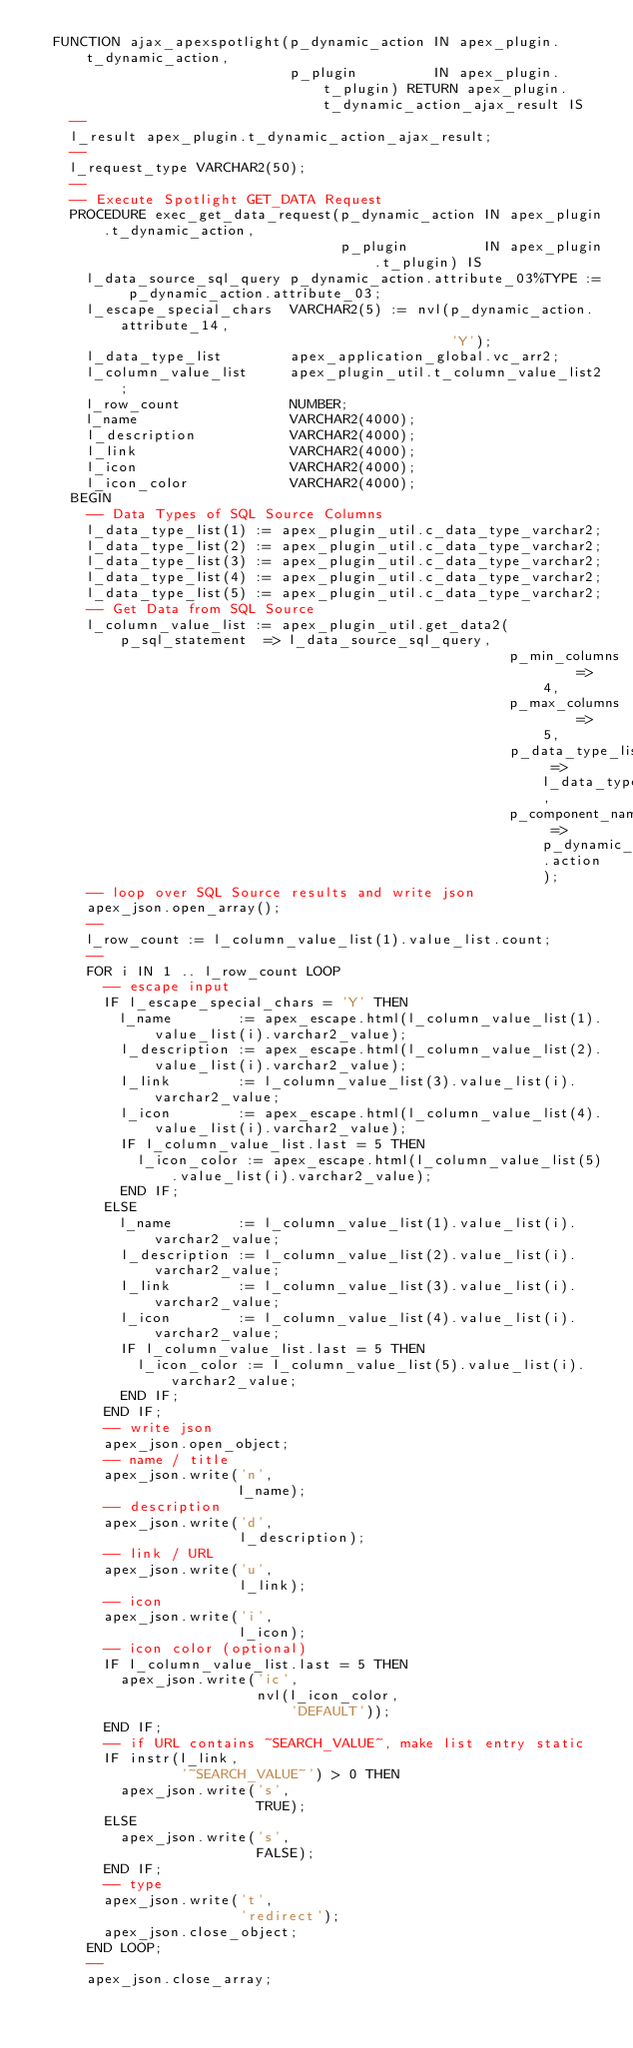Convert code to text. <code><loc_0><loc_0><loc_500><loc_500><_SQL_>  FUNCTION ajax_apexspotlight(p_dynamic_action IN apex_plugin.t_dynamic_action,
                              p_plugin         IN apex_plugin.t_plugin) RETURN apex_plugin.t_dynamic_action_ajax_result IS
    --
    l_result apex_plugin.t_dynamic_action_ajax_result;
    --
    l_request_type VARCHAR2(50);
    --
    -- Execute Spotlight GET_DATA Request
    PROCEDURE exec_get_data_request(p_dynamic_action IN apex_plugin.t_dynamic_action,
                                    p_plugin         IN apex_plugin.t_plugin) IS
      l_data_source_sql_query p_dynamic_action.attribute_03%TYPE := p_dynamic_action.attribute_03;
      l_escape_special_chars  VARCHAR2(5) := nvl(p_dynamic_action.attribute_14,
                                                 'Y');
      l_data_type_list        apex_application_global.vc_arr2;
      l_column_value_list     apex_plugin_util.t_column_value_list2;
      l_row_count             NUMBER;
      l_name                  VARCHAR2(4000);
      l_description           VARCHAR2(4000);
      l_link                  VARCHAR2(4000);
      l_icon                  VARCHAR2(4000);
      l_icon_color            VARCHAR2(4000);
    BEGIN
      -- Data Types of SQL Source Columns
      l_data_type_list(1) := apex_plugin_util.c_data_type_varchar2;
      l_data_type_list(2) := apex_plugin_util.c_data_type_varchar2;
      l_data_type_list(3) := apex_plugin_util.c_data_type_varchar2;
      l_data_type_list(4) := apex_plugin_util.c_data_type_varchar2;
      l_data_type_list(5) := apex_plugin_util.c_data_type_varchar2;
      -- Get Data from SQL Source
      l_column_value_list := apex_plugin_util.get_data2(p_sql_statement  => l_data_source_sql_query,
                                                        p_min_columns    => 4,
                                                        p_max_columns    => 5,
                                                        p_data_type_list => l_data_type_list,
                                                        p_component_name => p_dynamic_action.action);
      -- loop over SQL Source results and write json
      apex_json.open_array();
      --
      l_row_count := l_column_value_list(1).value_list.count;
      --
      FOR i IN 1 .. l_row_count LOOP
        -- escape input
        IF l_escape_special_chars = 'Y' THEN
          l_name        := apex_escape.html(l_column_value_list(1).value_list(i).varchar2_value);
          l_description := apex_escape.html(l_column_value_list(2).value_list(i).varchar2_value);
          l_link        := l_column_value_list(3).value_list(i).varchar2_value;
          l_icon        := apex_escape.html(l_column_value_list(4).value_list(i).varchar2_value);
          IF l_column_value_list.last = 5 THEN
            l_icon_color := apex_escape.html(l_column_value_list(5).value_list(i).varchar2_value);
          END IF;
        ELSE
          l_name        := l_column_value_list(1).value_list(i).varchar2_value;
          l_description := l_column_value_list(2).value_list(i).varchar2_value;
          l_link        := l_column_value_list(3).value_list(i).varchar2_value;
          l_icon        := l_column_value_list(4).value_list(i).varchar2_value;
          IF l_column_value_list.last = 5 THEN
            l_icon_color := l_column_value_list(5).value_list(i).varchar2_value;
          END IF;
        END IF;
        -- write json
        apex_json.open_object;
        -- name / title
        apex_json.write('n',
                        l_name);
        -- description
        apex_json.write('d',
                        l_description);
        -- link / URL
        apex_json.write('u',
                        l_link);
        -- icon
        apex_json.write('i',
                        l_icon);
        -- icon color (optional)
        IF l_column_value_list.last = 5 THEN
          apex_json.write('ic',
                          nvl(l_icon_color,
                              'DEFAULT'));
        END IF;
        -- if URL contains ~SEARCH_VALUE~, make list entry static
        IF instr(l_link,
                 '~SEARCH_VALUE~') > 0 THEN
          apex_json.write('s',
                          TRUE);
        ELSE
          apex_json.write('s',
                          FALSE);
        END IF;
        -- type
        apex_json.write('t',
                        'redirect');
        apex_json.close_object;
      END LOOP;
      --
      apex_json.close_array;</code> 